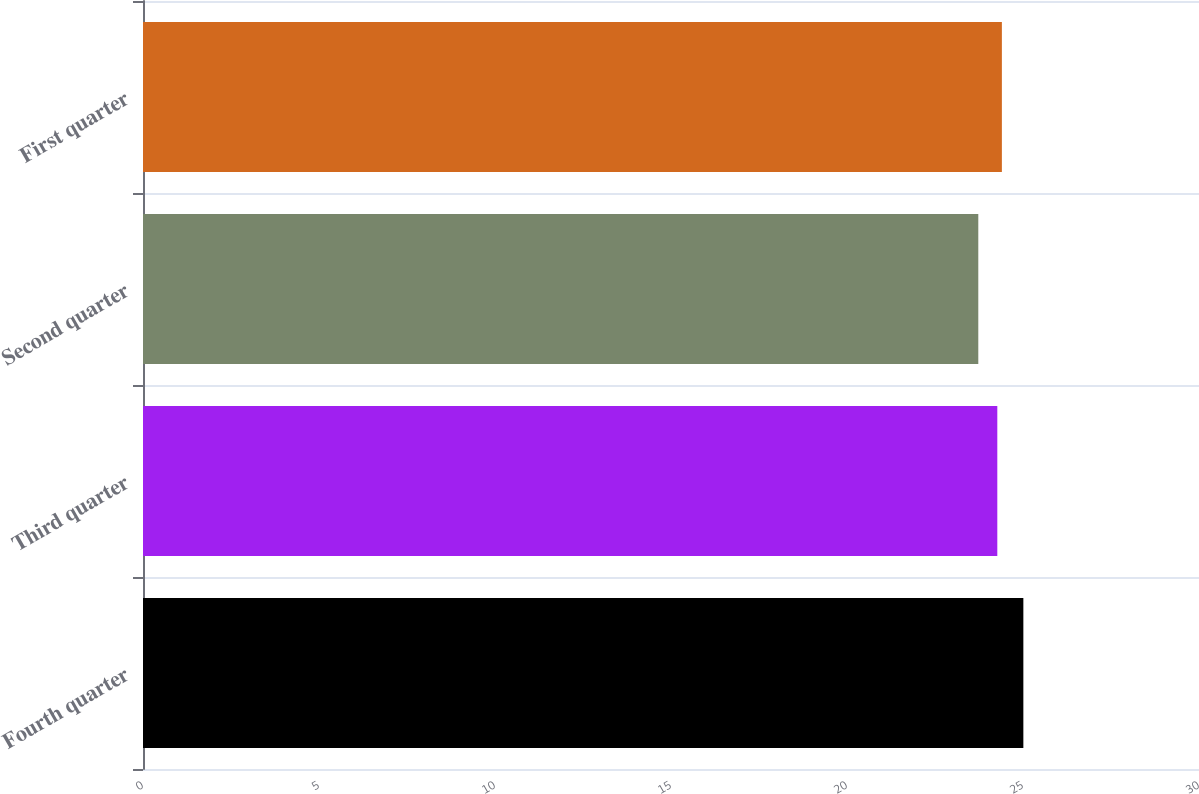<chart> <loc_0><loc_0><loc_500><loc_500><bar_chart><fcel>Fourth quarter<fcel>Third quarter<fcel>Second quarter<fcel>First quarter<nl><fcel>25.01<fcel>24.27<fcel>23.73<fcel>24.4<nl></chart> 